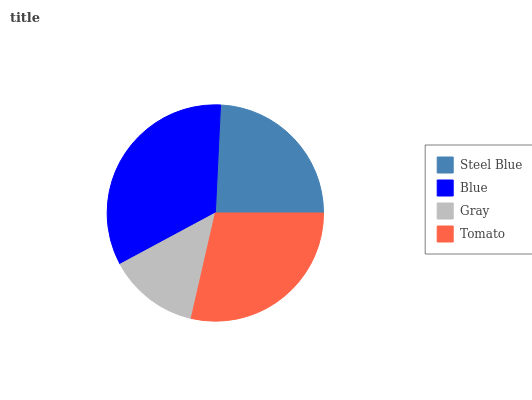Is Gray the minimum?
Answer yes or no. Yes. Is Blue the maximum?
Answer yes or no. Yes. Is Blue the minimum?
Answer yes or no. No. Is Gray the maximum?
Answer yes or no. No. Is Blue greater than Gray?
Answer yes or no. Yes. Is Gray less than Blue?
Answer yes or no. Yes. Is Gray greater than Blue?
Answer yes or no. No. Is Blue less than Gray?
Answer yes or no. No. Is Tomato the high median?
Answer yes or no. Yes. Is Steel Blue the low median?
Answer yes or no. Yes. Is Blue the high median?
Answer yes or no. No. Is Tomato the low median?
Answer yes or no. No. 